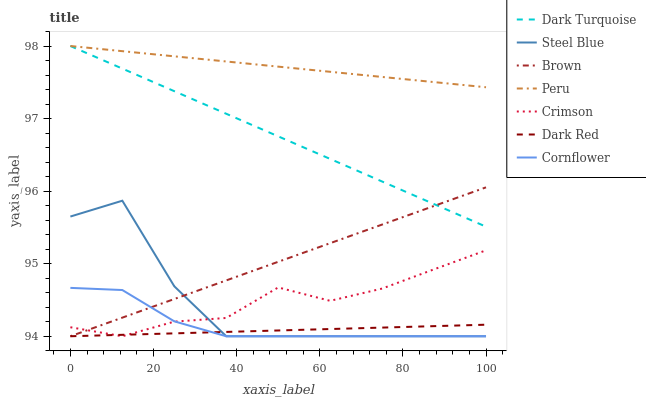Does Dark Red have the minimum area under the curve?
Answer yes or no. Yes. Does Peru have the maximum area under the curve?
Answer yes or no. Yes. Does Cornflower have the minimum area under the curve?
Answer yes or no. No. Does Cornflower have the maximum area under the curve?
Answer yes or no. No. Is Dark Red the smoothest?
Answer yes or no. Yes. Is Steel Blue the roughest?
Answer yes or no. Yes. Is Cornflower the smoothest?
Answer yes or no. No. Is Cornflower the roughest?
Answer yes or no. No. Does Brown have the lowest value?
Answer yes or no. Yes. Does Dark Turquoise have the lowest value?
Answer yes or no. No. Does Peru have the highest value?
Answer yes or no. Yes. Does Cornflower have the highest value?
Answer yes or no. No. Is Dark Red less than Peru?
Answer yes or no. Yes. Is Peru greater than Crimson?
Answer yes or no. Yes. Does Brown intersect Dark Turquoise?
Answer yes or no. Yes. Is Brown less than Dark Turquoise?
Answer yes or no. No. Is Brown greater than Dark Turquoise?
Answer yes or no. No. Does Dark Red intersect Peru?
Answer yes or no. No. 